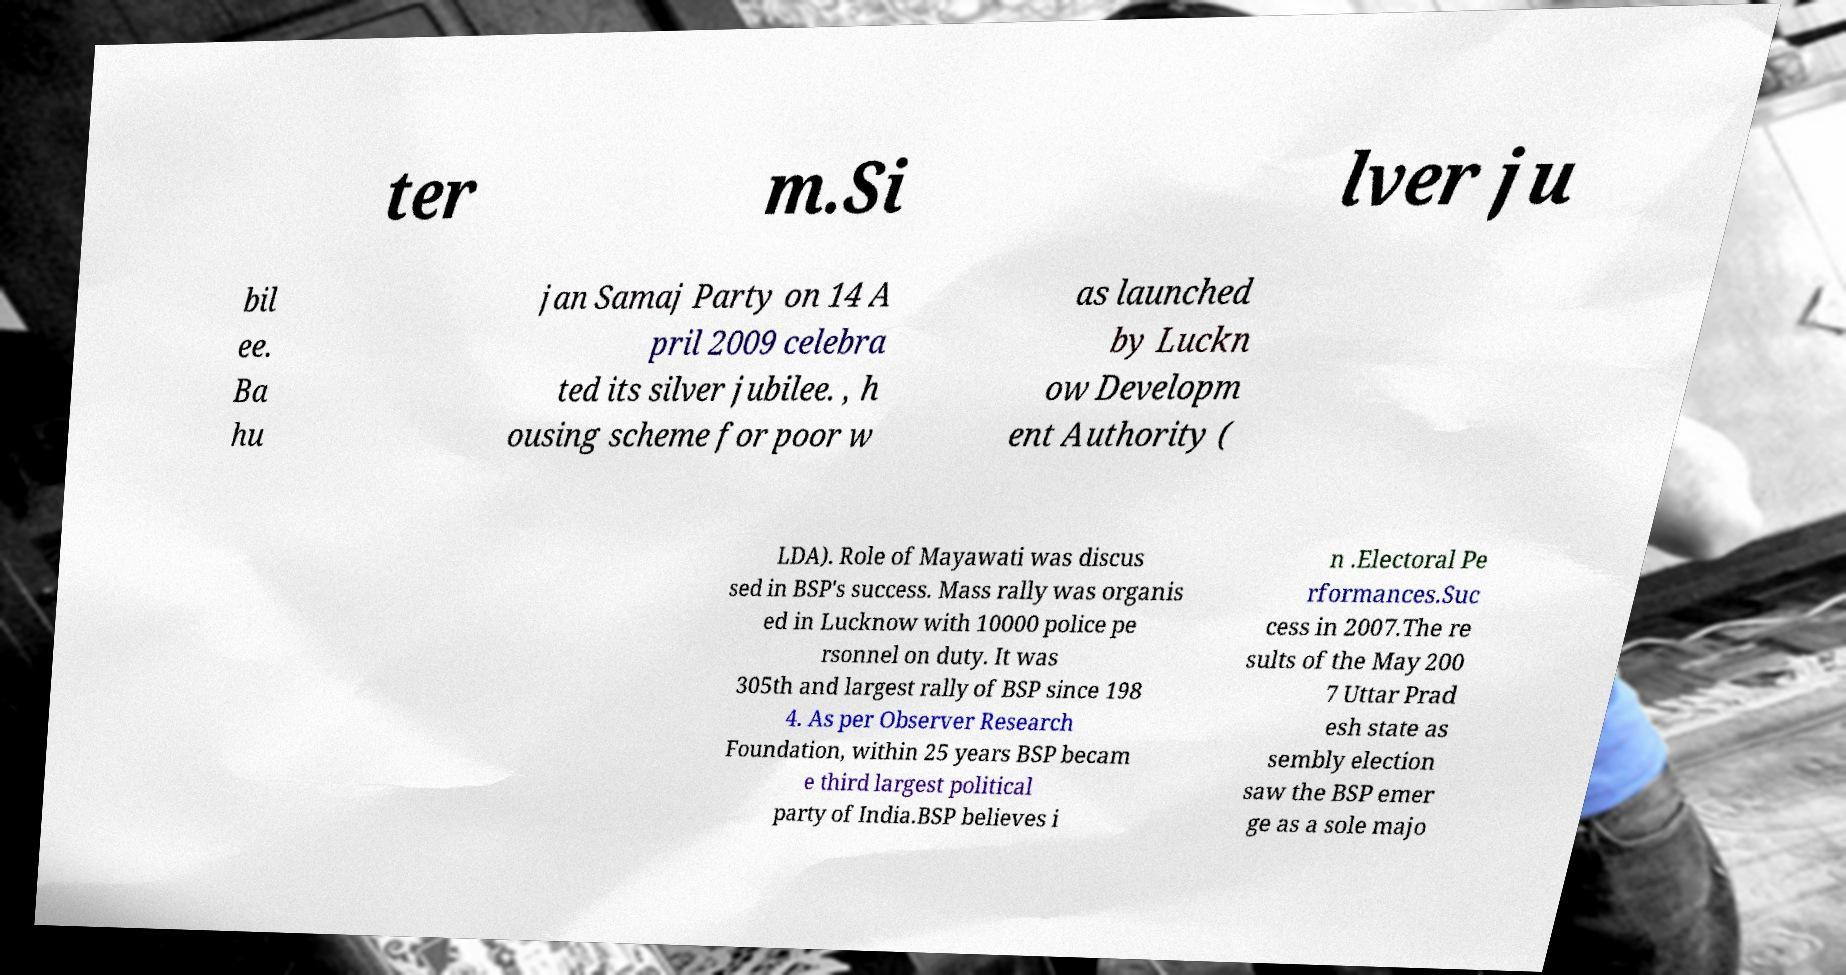Please read and relay the text visible in this image. What does it say? ter m.Si lver ju bil ee. Ba hu jan Samaj Party on 14 A pril 2009 celebra ted its silver jubilee. , h ousing scheme for poor w as launched by Luckn ow Developm ent Authority ( LDA). Role of Mayawati was discus sed in BSP's success. Mass rally was organis ed in Lucknow with 10000 police pe rsonnel on duty. It was 305th and largest rally of BSP since 198 4. As per Observer Research Foundation, within 25 years BSP becam e third largest political party of India.BSP believes i n .Electoral Pe rformances.Suc cess in 2007.The re sults of the May 200 7 Uttar Prad esh state as sembly election saw the BSP emer ge as a sole majo 